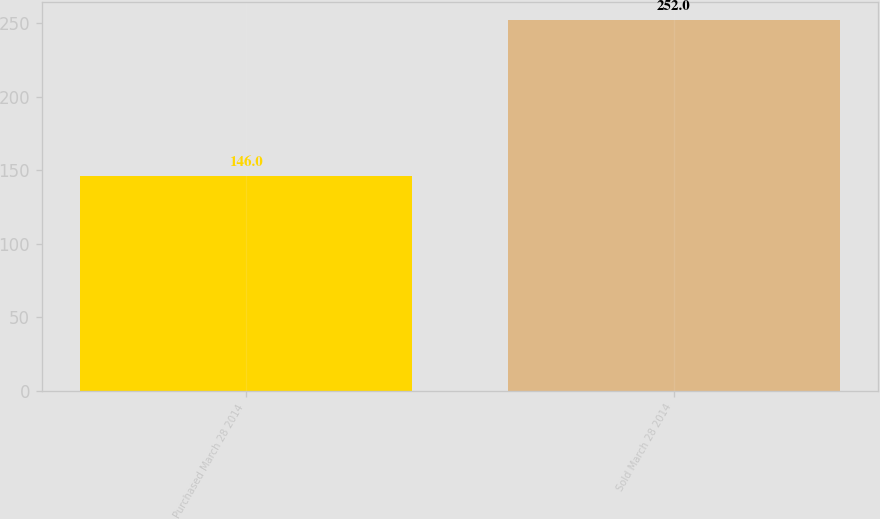Convert chart. <chart><loc_0><loc_0><loc_500><loc_500><bar_chart><fcel>Purchased March 28 2014<fcel>Sold March 28 2014<nl><fcel>146<fcel>252<nl></chart> 